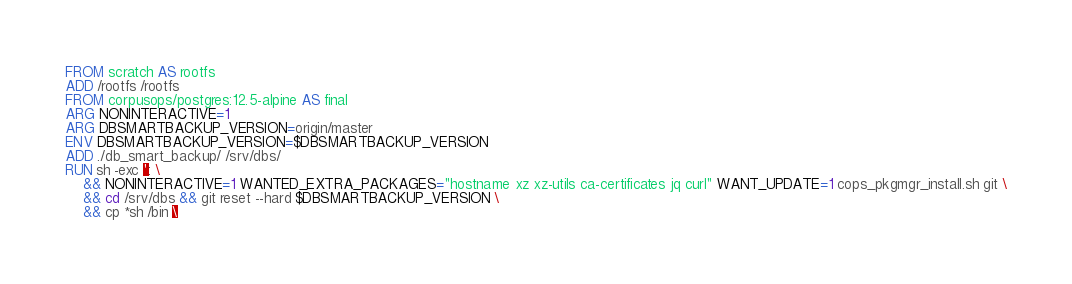Convert code to text. <code><loc_0><loc_0><loc_500><loc_500><_Dockerfile_>FROM scratch AS rootfs
ADD /rootfs /rootfs
FROM corpusops/postgres:12.5-alpine AS final
ARG NONINTERACTIVE=1
ARG DBSMARTBACKUP_VERSION=origin/master
ENV DBSMARTBACKUP_VERSION=$DBSMARTBACKUP_VERSION
ADD ./db_smart_backup/ /srv/dbs/
RUN sh -exc ': \
    && NONINTERACTIVE=1 WANTED_EXTRA_PACKAGES="hostname xz xz-utils ca-certificates jq curl" WANT_UPDATE=1 cops_pkgmgr_install.sh git \
    && cd /srv/dbs && git reset --hard $DBSMARTBACKUP_VERSION \
    && cp *sh /bin \</code> 